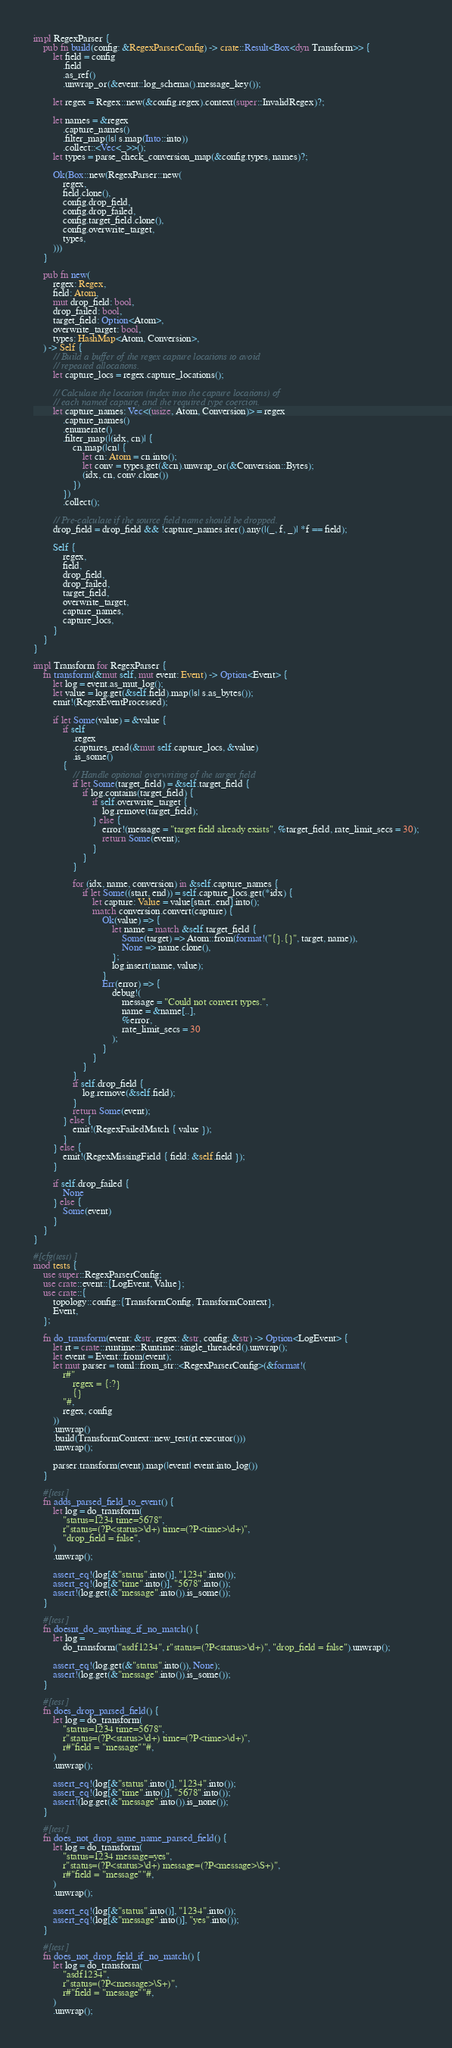Convert code to text. <code><loc_0><loc_0><loc_500><loc_500><_Rust_>impl RegexParser {
    pub fn build(config: &RegexParserConfig) -> crate::Result<Box<dyn Transform>> {
        let field = config
            .field
            .as_ref()
            .unwrap_or(&event::log_schema().message_key());

        let regex = Regex::new(&config.regex).context(super::InvalidRegex)?;

        let names = &regex
            .capture_names()
            .filter_map(|s| s.map(Into::into))
            .collect::<Vec<_>>();
        let types = parse_check_conversion_map(&config.types, names)?;

        Ok(Box::new(RegexParser::new(
            regex,
            field.clone(),
            config.drop_field,
            config.drop_failed,
            config.target_field.clone(),
            config.overwrite_target,
            types,
        )))
    }

    pub fn new(
        regex: Regex,
        field: Atom,
        mut drop_field: bool,
        drop_failed: bool,
        target_field: Option<Atom>,
        overwrite_target: bool,
        types: HashMap<Atom, Conversion>,
    ) -> Self {
        // Build a buffer of the regex capture locations to avoid
        // repeated allocations.
        let capture_locs = regex.capture_locations();

        // Calculate the location (index into the capture locations) of
        // each named capture, and the required type coercion.
        let capture_names: Vec<(usize, Atom, Conversion)> = regex
            .capture_names()
            .enumerate()
            .filter_map(|(idx, cn)| {
                cn.map(|cn| {
                    let cn: Atom = cn.into();
                    let conv = types.get(&cn).unwrap_or(&Conversion::Bytes);
                    (idx, cn, conv.clone())
                })
            })
            .collect();

        // Pre-calculate if the source field name should be dropped.
        drop_field = drop_field && !capture_names.iter().any(|(_, f, _)| *f == field);

        Self {
            regex,
            field,
            drop_field,
            drop_failed,
            target_field,
            overwrite_target,
            capture_names,
            capture_locs,
        }
    }
}

impl Transform for RegexParser {
    fn transform(&mut self, mut event: Event) -> Option<Event> {
        let log = event.as_mut_log();
        let value = log.get(&self.field).map(|s| s.as_bytes());
        emit!(RegexEventProcessed);

        if let Some(value) = &value {
            if self
                .regex
                .captures_read(&mut self.capture_locs, &value)
                .is_some()
            {
                // Handle optional overwriting of the target field
                if let Some(target_field) = &self.target_field {
                    if log.contains(target_field) {
                        if self.overwrite_target {
                            log.remove(target_field);
                        } else {
                            error!(message = "target field already exists", %target_field, rate_limit_secs = 30);
                            return Some(event);
                        }
                    }
                }

                for (idx, name, conversion) in &self.capture_names {
                    if let Some((start, end)) = self.capture_locs.get(*idx) {
                        let capture: Value = value[start..end].into();
                        match conversion.convert(capture) {
                            Ok(value) => {
                                let name = match &self.target_field {
                                    Some(target) => Atom::from(format!("{}.{}", target, name)),
                                    None => name.clone(),
                                };
                                log.insert(name, value);
                            }
                            Err(error) => {
                                debug!(
                                    message = "Could not convert types.",
                                    name = &name[..],
                                    %error,
                                    rate_limit_secs = 30
                                );
                            }
                        }
                    }
                }
                if self.drop_field {
                    log.remove(&self.field);
                }
                return Some(event);
            } else {
                emit!(RegexFailedMatch { value });
            }
        } else {
            emit!(RegexMissingField { field: &self.field });
        }

        if self.drop_failed {
            None
        } else {
            Some(event)
        }
    }
}

#[cfg(test)]
mod tests {
    use super::RegexParserConfig;
    use crate::event::{LogEvent, Value};
    use crate::{
        topology::config::{TransformConfig, TransformContext},
        Event,
    };

    fn do_transform(event: &str, regex: &str, config: &str) -> Option<LogEvent> {
        let rt = crate::runtime::Runtime::single_threaded().unwrap();
        let event = Event::from(event);
        let mut parser = toml::from_str::<RegexParserConfig>(&format!(
            r#"
                regex = {:?}
                {}
            "#,
            regex, config
        ))
        .unwrap()
        .build(TransformContext::new_test(rt.executor()))
        .unwrap();

        parser.transform(event).map(|event| event.into_log())
    }

    #[test]
    fn adds_parsed_field_to_event() {
        let log = do_transform(
            "status=1234 time=5678",
            r"status=(?P<status>\d+) time=(?P<time>\d+)",
            "drop_field = false",
        )
        .unwrap();

        assert_eq!(log[&"status".into()], "1234".into());
        assert_eq!(log[&"time".into()], "5678".into());
        assert!(log.get(&"message".into()).is_some());
    }

    #[test]
    fn doesnt_do_anything_if_no_match() {
        let log =
            do_transform("asdf1234", r"status=(?P<status>\d+)", "drop_field = false").unwrap();

        assert_eq!(log.get(&"status".into()), None);
        assert!(log.get(&"message".into()).is_some());
    }

    #[test]
    fn does_drop_parsed_field() {
        let log = do_transform(
            "status=1234 time=5678",
            r"status=(?P<status>\d+) time=(?P<time>\d+)",
            r#"field = "message""#,
        )
        .unwrap();

        assert_eq!(log[&"status".into()], "1234".into());
        assert_eq!(log[&"time".into()], "5678".into());
        assert!(log.get(&"message".into()).is_none());
    }

    #[test]
    fn does_not_drop_same_name_parsed_field() {
        let log = do_transform(
            "status=1234 message=yes",
            r"status=(?P<status>\d+) message=(?P<message>\S+)",
            r#"field = "message""#,
        )
        .unwrap();

        assert_eq!(log[&"status".into()], "1234".into());
        assert_eq!(log[&"message".into()], "yes".into());
    }

    #[test]
    fn does_not_drop_field_if_no_match() {
        let log = do_transform(
            "asdf1234",
            r"status=(?P<message>\S+)",
            r#"field = "message""#,
        )
        .unwrap();
</code> 